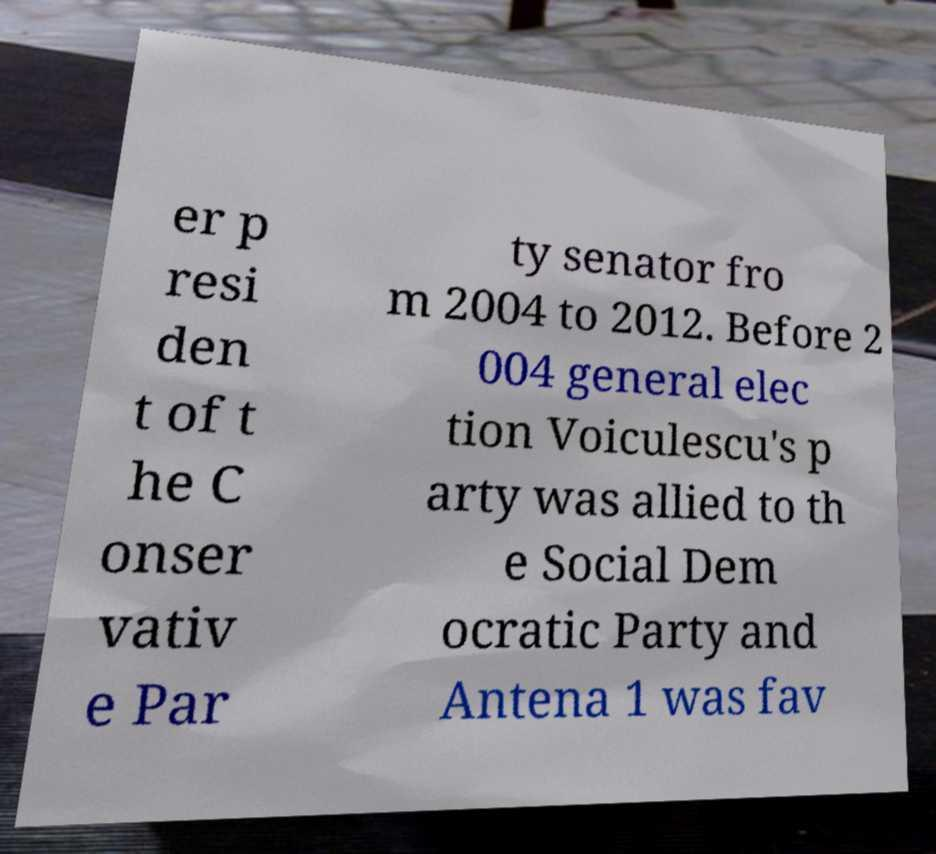Please identify and transcribe the text found in this image. er p resi den t of t he C onser vativ e Par ty senator fro m 2004 to 2012. Before 2 004 general elec tion Voiculescu's p arty was allied to th e Social Dem ocratic Party and Antena 1 was fav 